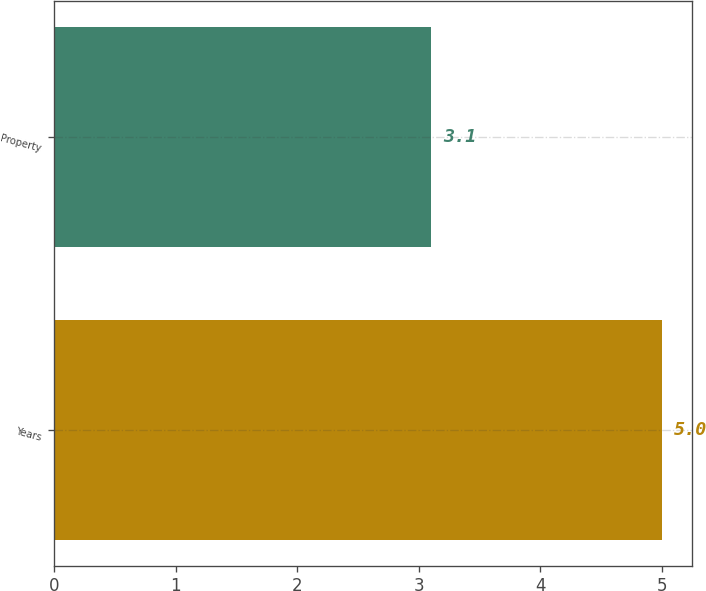<chart> <loc_0><loc_0><loc_500><loc_500><bar_chart><fcel>Years<fcel>Property<nl><fcel>5<fcel>3.1<nl></chart> 